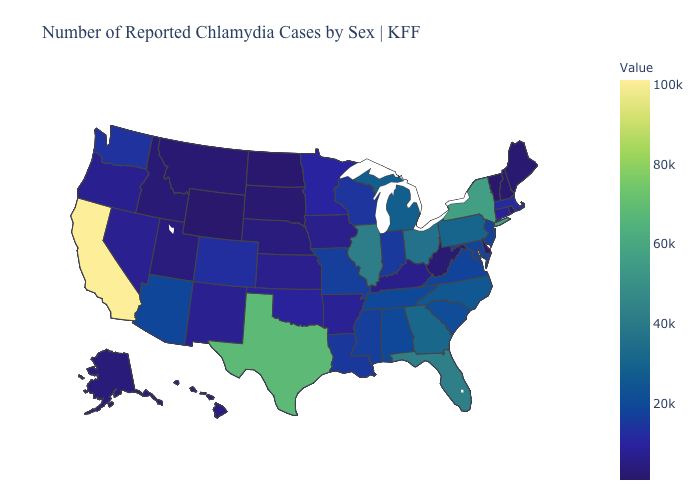Which states have the lowest value in the Northeast?
Keep it brief. Vermont. Among the states that border Nevada , does Arizona have the highest value?
Keep it brief. No. Among the states that border Washington , which have the highest value?
Answer briefly. Oregon. Does Massachusetts have the lowest value in the USA?
Answer briefly. No. Does Illinois have the highest value in the USA?
Answer briefly. No. 